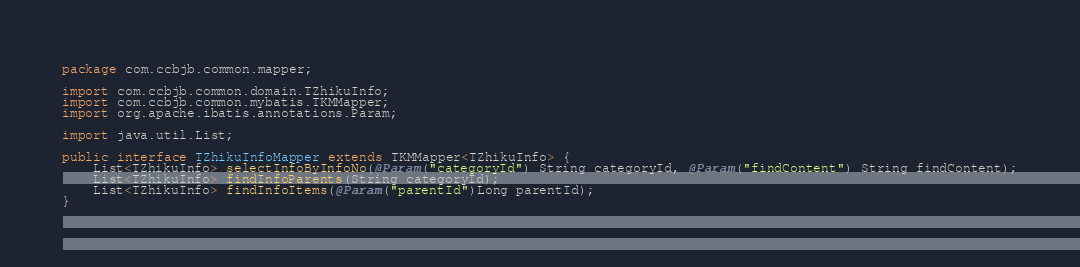Convert code to text. <code><loc_0><loc_0><loc_500><loc_500><_Java_>package com.ccbjb.common.mapper;

import com.ccbjb.common.domain.TZhikuInfo;
import com.ccbjb.common.mybatis.TKMMapper;
import org.apache.ibatis.annotations.Param;

import java.util.List;

public interface TZhikuInfoMapper extends TKMMapper<TZhikuInfo> {
    List<TZhikuInfo> selectInfoByInfoNo(@Param("categoryId") String categoryId, @Param("findContent") String findContent);
    List<TZhikuInfo> findInfoParents(String categoryId);
    List<TZhikuInfo> findInfoItems(@Param("parentId")Long parentId);
}
</code> 